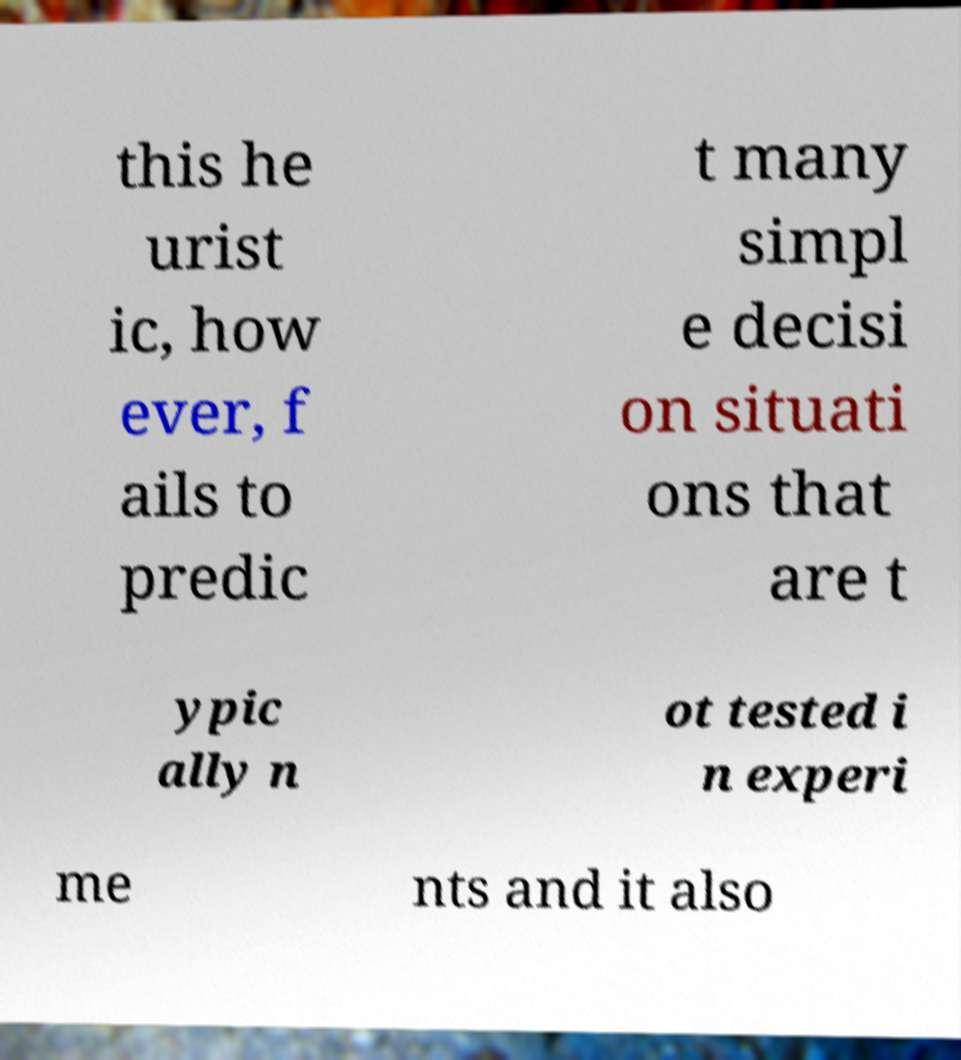Could you assist in decoding the text presented in this image and type it out clearly? this he urist ic, how ever, f ails to predic t many simpl e decisi on situati ons that are t ypic ally n ot tested i n experi me nts and it also 